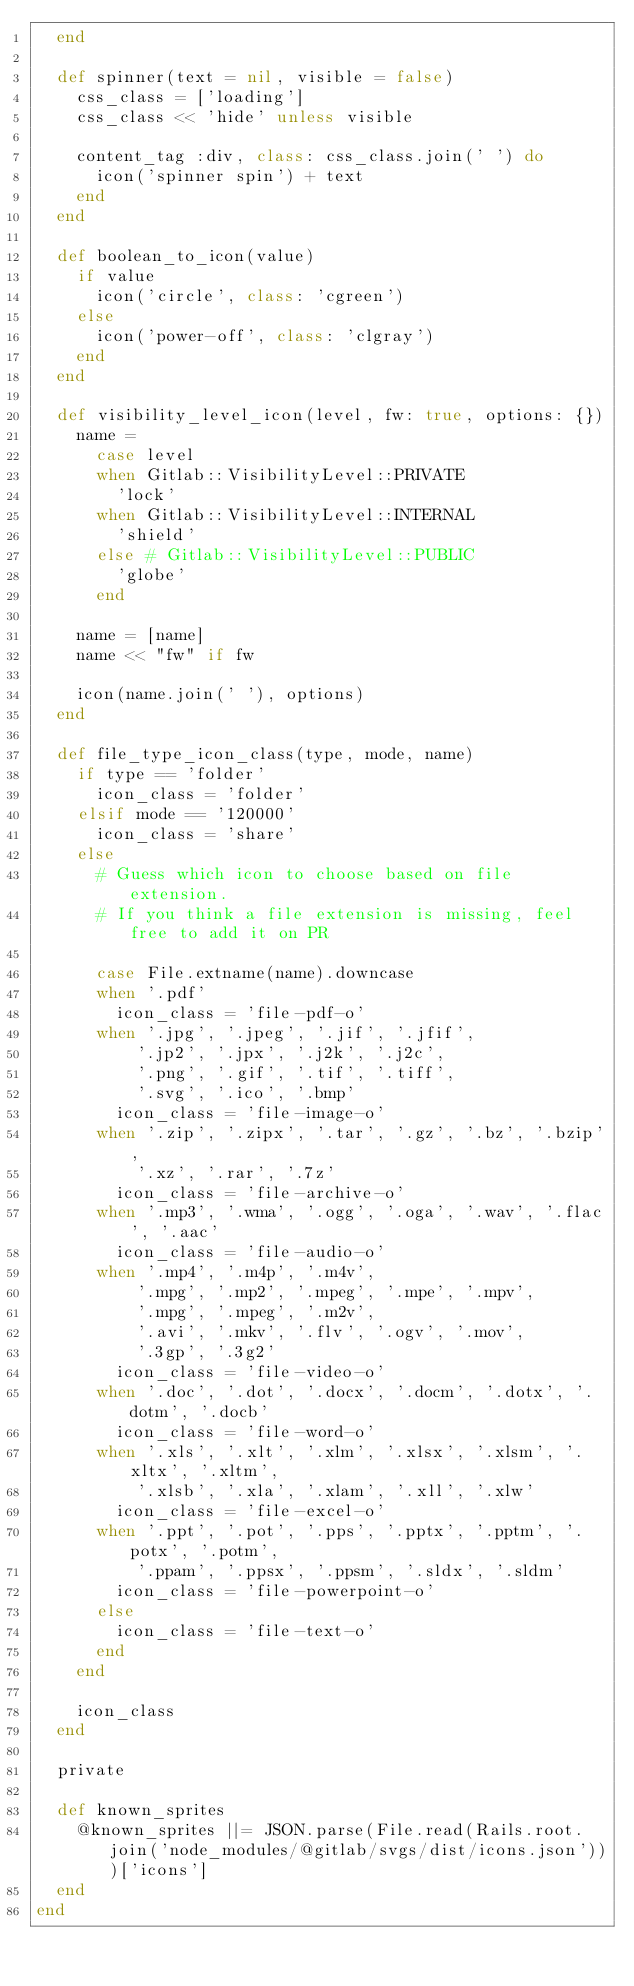<code> <loc_0><loc_0><loc_500><loc_500><_Ruby_>  end

  def spinner(text = nil, visible = false)
    css_class = ['loading']
    css_class << 'hide' unless visible

    content_tag :div, class: css_class.join(' ') do
      icon('spinner spin') + text
    end
  end

  def boolean_to_icon(value)
    if value
      icon('circle', class: 'cgreen')
    else
      icon('power-off', class: 'clgray')
    end
  end

  def visibility_level_icon(level, fw: true, options: {})
    name =
      case level
      when Gitlab::VisibilityLevel::PRIVATE
        'lock'
      when Gitlab::VisibilityLevel::INTERNAL
        'shield'
      else # Gitlab::VisibilityLevel::PUBLIC
        'globe'
      end

    name = [name]
    name << "fw" if fw

    icon(name.join(' '), options)
  end

  def file_type_icon_class(type, mode, name)
    if type == 'folder'
      icon_class = 'folder'
    elsif mode == '120000'
      icon_class = 'share'
    else
      # Guess which icon to choose based on file extension.
      # If you think a file extension is missing, feel free to add it on PR

      case File.extname(name).downcase
      when '.pdf'
        icon_class = 'file-pdf-o'
      when '.jpg', '.jpeg', '.jif', '.jfif',
          '.jp2', '.jpx', '.j2k', '.j2c',
          '.png', '.gif', '.tif', '.tiff',
          '.svg', '.ico', '.bmp'
        icon_class = 'file-image-o'
      when '.zip', '.zipx', '.tar', '.gz', '.bz', '.bzip',
          '.xz', '.rar', '.7z'
        icon_class = 'file-archive-o'
      when '.mp3', '.wma', '.ogg', '.oga', '.wav', '.flac', '.aac'
        icon_class = 'file-audio-o'
      when '.mp4', '.m4p', '.m4v',
          '.mpg', '.mp2', '.mpeg', '.mpe', '.mpv',
          '.mpg', '.mpeg', '.m2v',
          '.avi', '.mkv', '.flv', '.ogv', '.mov',
          '.3gp', '.3g2'
        icon_class = 'file-video-o'
      when '.doc', '.dot', '.docx', '.docm', '.dotx', '.dotm', '.docb'
        icon_class = 'file-word-o'
      when '.xls', '.xlt', '.xlm', '.xlsx', '.xlsm', '.xltx', '.xltm',
          '.xlsb', '.xla', '.xlam', '.xll', '.xlw'
        icon_class = 'file-excel-o'
      when '.ppt', '.pot', '.pps', '.pptx', '.pptm', '.potx', '.potm',
          '.ppam', '.ppsx', '.ppsm', '.sldx', '.sldm'
        icon_class = 'file-powerpoint-o'
      else
        icon_class = 'file-text-o'
      end
    end

    icon_class
  end

  private

  def known_sprites
    @known_sprites ||= JSON.parse(File.read(Rails.root.join('node_modules/@gitlab/svgs/dist/icons.json')))['icons']
  end
end
</code> 